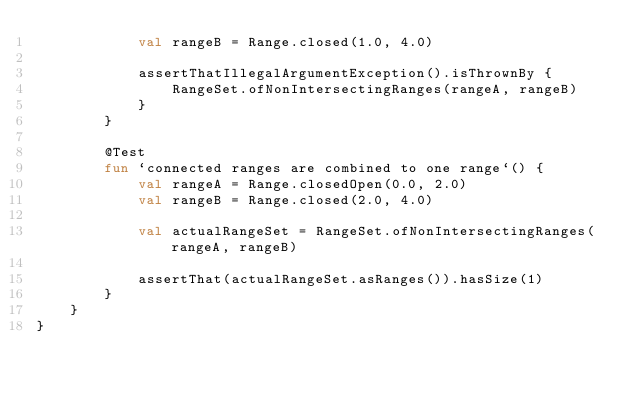Convert code to text. <code><loc_0><loc_0><loc_500><loc_500><_Kotlin_>            val rangeB = Range.closed(1.0, 4.0)

            assertThatIllegalArgumentException().isThrownBy {
                RangeSet.ofNonIntersectingRanges(rangeA, rangeB)
            }
        }

        @Test
        fun `connected ranges are combined to one range`() {
            val rangeA = Range.closedOpen(0.0, 2.0)
            val rangeB = Range.closed(2.0, 4.0)

            val actualRangeSet = RangeSet.ofNonIntersectingRanges(rangeA, rangeB)

            assertThat(actualRangeSet.asRanges()).hasSize(1)
        }
    }
}
</code> 